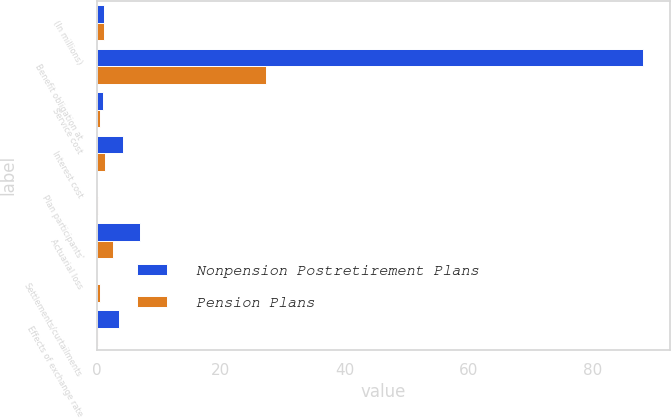<chart> <loc_0><loc_0><loc_500><loc_500><stacked_bar_chart><ecel><fcel>(In millions)<fcel>Benefit obligation at<fcel>Service cost<fcel>Interest cost<fcel>Plan participants'<fcel>Actuarial loss<fcel>Settlements/curtailments<fcel>Effects of exchange rate<nl><fcel>Nonpension Postretirement Plans<fcel>1.05<fcel>88.1<fcel>0.9<fcel>4.2<fcel>0<fcel>7<fcel>0<fcel>3.6<nl><fcel>Pension Plans<fcel>1.05<fcel>27.2<fcel>0.4<fcel>1.2<fcel>0.2<fcel>2.5<fcel>0.4<fcel>0.1<nl></chart> 